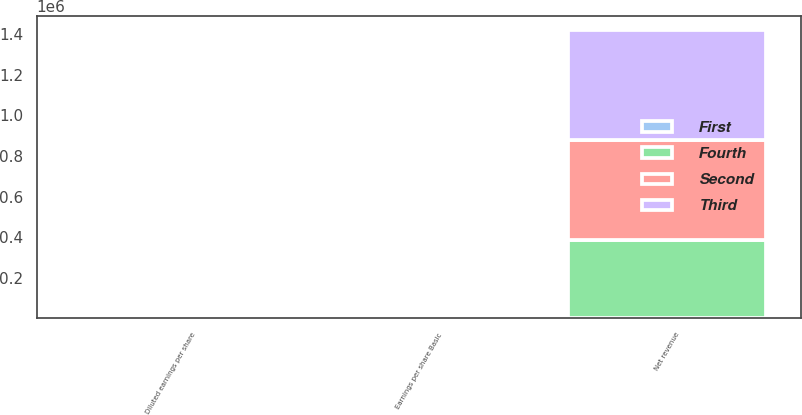Convert chart. <chart><loc_0><loc_0><loc_500><loc_500><stacked_bar_chart><ecel><fcel>Net revenue<fcel>Earnings per share Basic<fcel>Diluted earnings per share<nl><fcel>Fourth<fcel>387982<fcel>0.63<fcel>0.62<nl><fcel>Second<fcel>492667<fcel>0.22<fcel>0.22<nl><fcel>First<fcel>0.63<fcel>1.59<fcel>1.57<nl><fcel>Third<fcel>539007<fcel>0.5<fcel>0.5<nl></chart> 